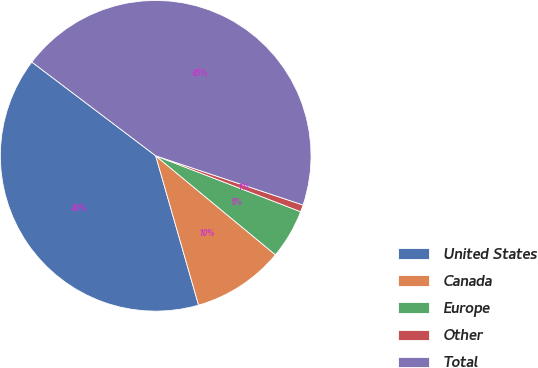<chart> <loc_0><loc_0><loc_500><loc_500><pie_chart><fcel>United States<fcel>Canada<fcel>Europe<fcel>Other<fcel>Total<nl><fcel>39.76%<fcel>9.55%<fcel>5.14%<fcel>0.73%<fcel>44.81%<nl></chart> 